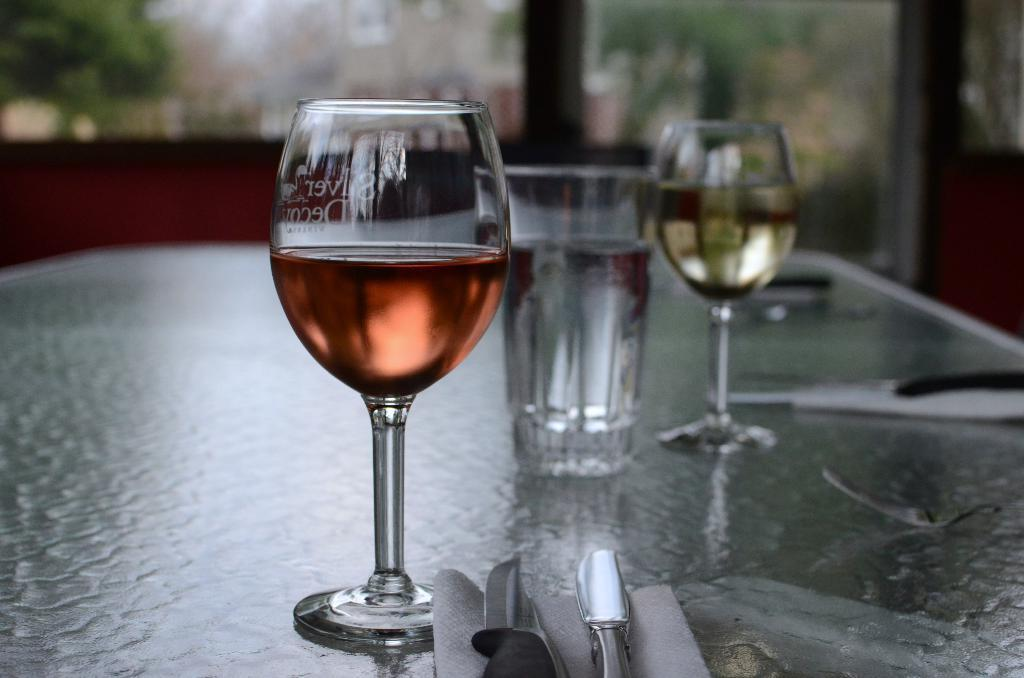What type of glasses are present in the image? There are wine glasses in the image. What is inside the wine glasses? The wine glasses are filled with wine. Where are the wine glasses located? The wine glasses are on a table. What other items can be seen on the table? There are knives on the table. What grade does the man sitting at the table receive for his performance in the image? There is no man present in the image, and therefore no performance to grade. 